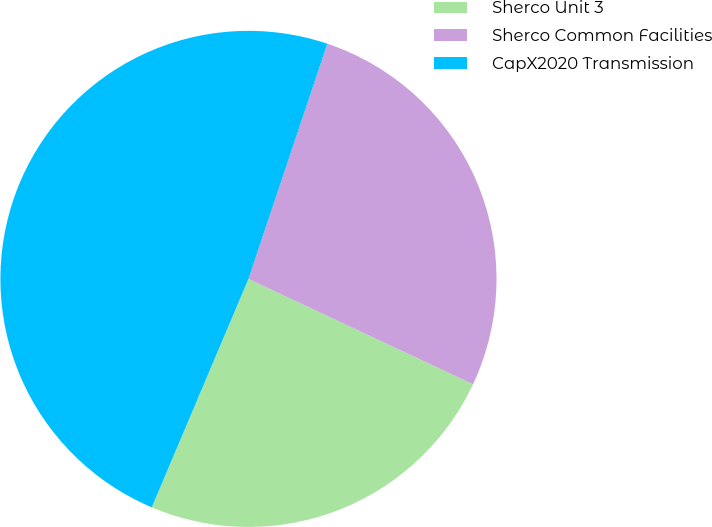Convert chart to OTSL. <chart><loc_0><loc_0><loc_500><loc_500><pie_chart><fcel>Sherco Unit 3<fcel>Sherco Common Facilities<fcel>CapX2020 Transmission<nl><fcel>24.39%<fcel>26.83%<fcel>48.78%<nl></chart> 